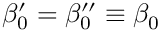<formula> <loc_0><loc_0><loc_500><loc_500>\beta _ { 0 } ^ { \prime } = \beta _ { 0 } ^ { \prime \prime } \equiv \beta _ { 0 }</formula> 